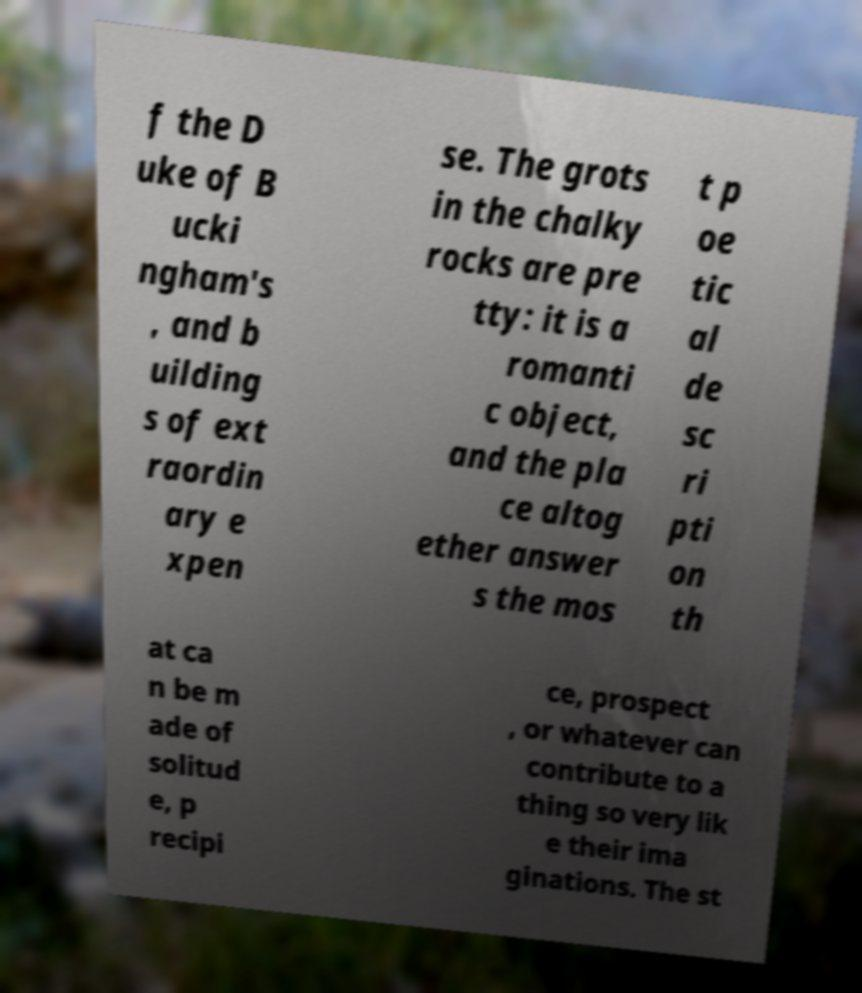I need the written content from this picture converted into text. Can you do that? f the D uke of B ucki ngham's , and b uilding s of ext raordin ary e xpen se. The grots in the chalky rocks are pre tty: it is a romanti c object, and the pla ce altog ether answer s the mos t p oe tic al de sc ri pti on th at ca n be m ade of solitud e, p recipi ce, prospect , or whatever can contribute to a thing so very lik e their ima ginations. The st 